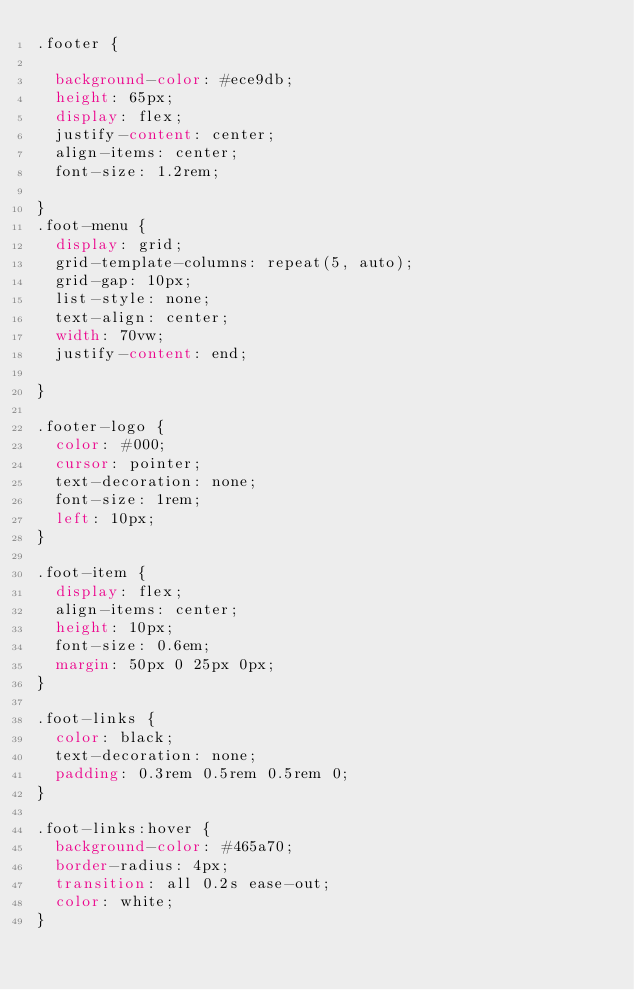Convert code to text. <code><loc_0><loc_0><loc_500><loc_500><_CSS_>.footer {
  
  background-color: #ece9db;
  height: 65px;
  display: flex;
  justify-content: center;
  align-items: center;
  font-size: 1.2rem;
  
}
.foot-menu {
  display: grid;
  grid-template-columns: repeat(5, auto);
  grid-gap: 10px;
  list-style: none;
  text-align: center;
  width: 70vw;
  justify-content: end;
 
}

.footer-logo {
  color: #000;
  cursor: pointer;
  text-decoration: none;
  font-size: 1rem;
  left: 10px;
}

.foot-item {
  display: flex;
  align-items: center;
  height: 10px;
  font-size: 0.6em;
  margin: 50px 0 25px 0px;
}

.foot-links {
  color: black;
  text-decoration: none;
  padding: 0.3rem 0.5rem 0.5rem 0;
}

.foot-links:hover {
  background-color: #465a70;
  border-radius: 4px;
  transition: all 0.2s ease-out;
  color: white;
}
</code> 